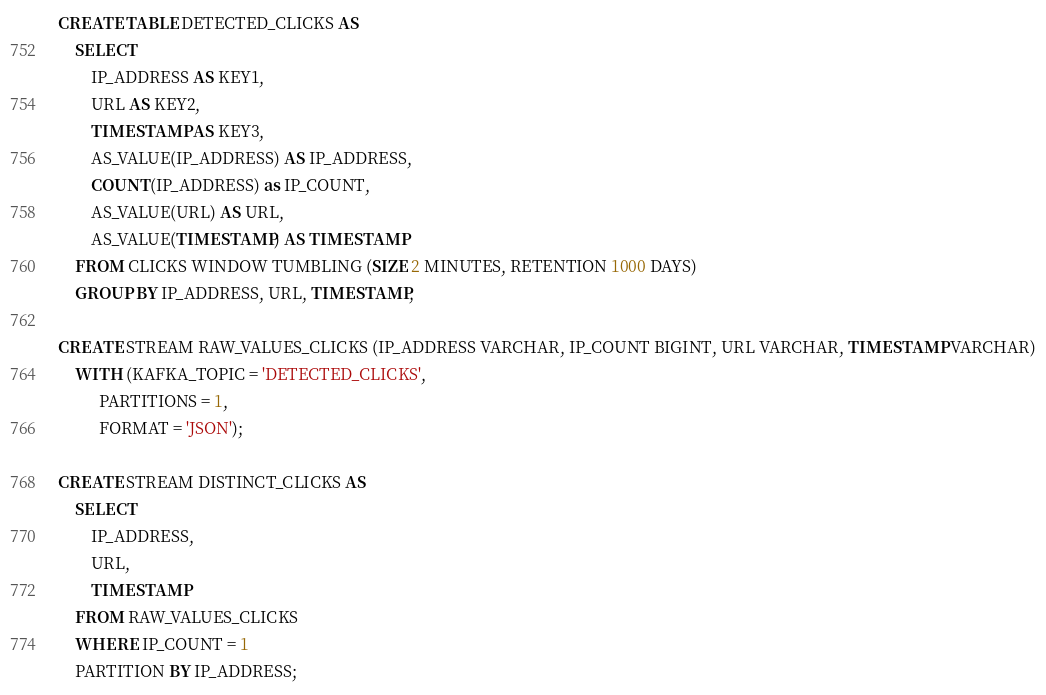Convert code to text. <code><loc_0><loc_0><loc_500><loc_500><_SQL_>CREATE TABLE DETECTED_CLICKS AS
    SELECT
        IP_ADDRESS AS KEY1,
        URL AS KEY2,
        TIMESTAMP AS KEY3,
        AS_VALUE(IP_ADDRESS) AS IP_ADDRESS,
        COUNT(IP_ADDRESS) as IP_COUNT,
        AS_VALUE(URL) AS URL,
        AS_VALUE(TIMESTAMP) AS TIMESTAMP
    FROM CLICKS WINDOW TUMBLING (SIZE 2 MINUTES, RETENTION 1000 DAYS)
    GROUP BY IP_ADDRESS, URL, TIMESTAMP;

CREATE STREAM RAW_VALUES_CLICKS (IP_ADDRESS VARCHAR, IP_COUNT BIGINT, URL VARCHAR, TIMESTAMP VARCHAR)
    WITH (KAFKA_TOPIC = 'DETECTED_CLICKS',
          PARTITIONS = 1,
          FORMAT = 'JSON');

CREATE STREAM DISTINCT_CLICKS AS
    SELECT
        IP_ADDRESS,
        URL,
        TIMESTAMP
    FROM RAW_VALUES_CLICKS
    WHERE IP_COUNT = 1
    PARTITION BY IP_ADDRESS;
</code> 